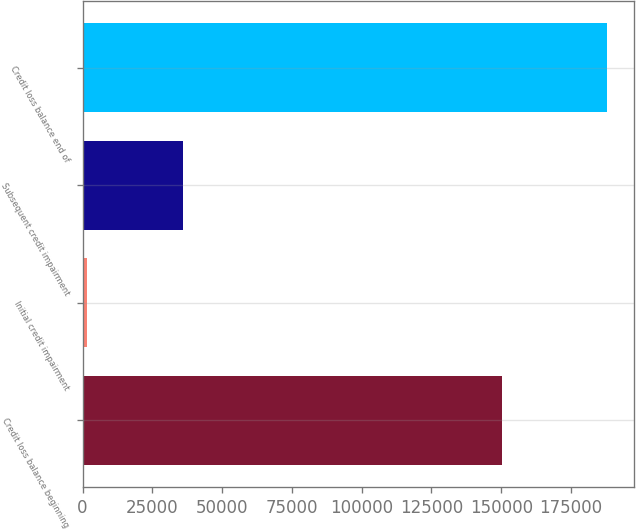Convert chart to OTSL. <chart><loc_0><loc_0><loc_500><loc_500><bar_chart><fcel>Credit loss balance beginning<fcel>Initial credit impairment<fcel>Subsequent credit impairment<fcel>Credit loss balance end of<nl><fcel>150372<fcel>1642<fcel>36024<fcel>188038<nl></chart> 